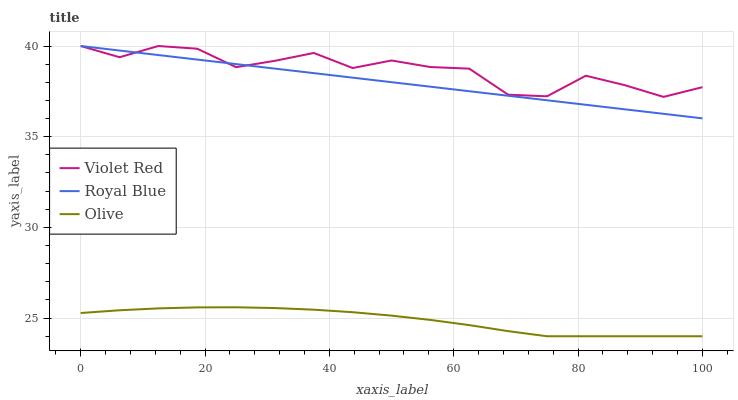Does Olive have the minimum area under the curve?
Answer yes or no. Yes. Does Violet Red have the maximum area under the curve?
Answer yes or no. Yes. Does Royal Blue have the minimum area under the curve?
Answer yes or no. No. Does Royal Blue have the maximum area under the curve?
Answer yes or no. No. Is Royal Blue the smoothest?
Answer yes or no. Yes. Is Violet Red the roughest?
Answer yes or no. Yes. Is Violet Red the smoothest?
Answer yes or no. No. Is Royal Blue the roughest?
Answer yes or no. No. Does Olive have the lowest value?
Answer yes or no. Yes. Does Royal Blue have the lowest value?
Answer yes or no. No. Does Violet Red have the highest value?
Answer yes or no. Yes. Is Olive less than Royal Blue?
Answer yes or no. Yes. Is Violet Red greater than Olive?
Answer yes or no. Yes. Does Violet Red intersect Royal Blue?
Answer yes or no. Yes. Is Violet Red less than Royal Blue?
Answer yes or no. No. Is Violet Red greater than Royal Blue?
Answer yes or no. No. Does Olive intersect Royal Blue?
Answer yes or no. No. 